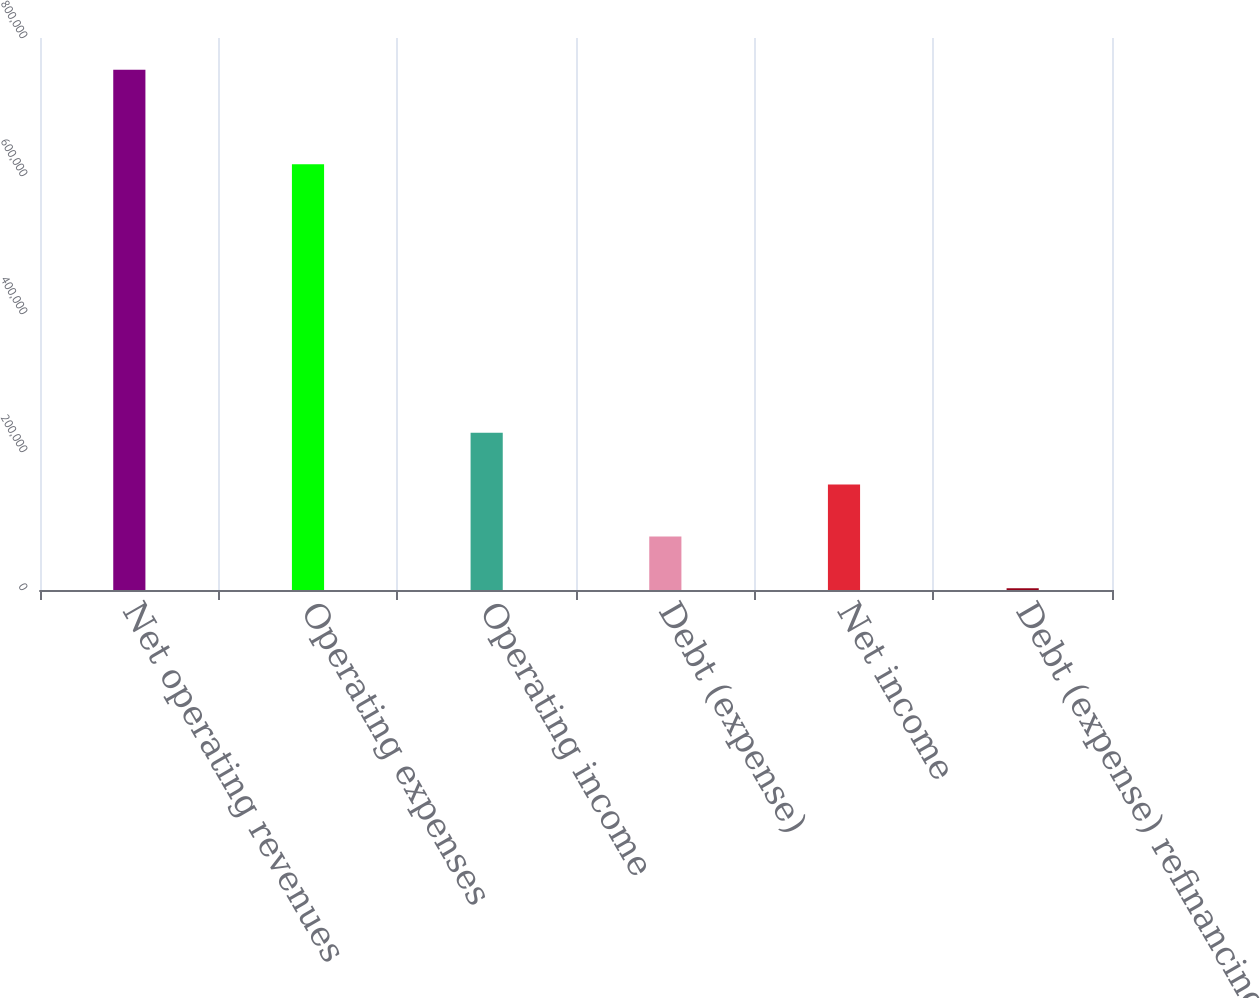Convert chart to OTSL. <chart><loc_0><loc_0><loc_500><loc_500><bar_chart><fcel>Net operating revenues<fcel>Operating expenses<fcel>Operating income<fcel>Debt (expense)<fcel>Net income<fcel>Debt (expense) refinancing<nl><fcel>754163<fcel>617159<fcel>227995<fcel>77661.8<fcel>152829<fcel>2495<nl></chart> 